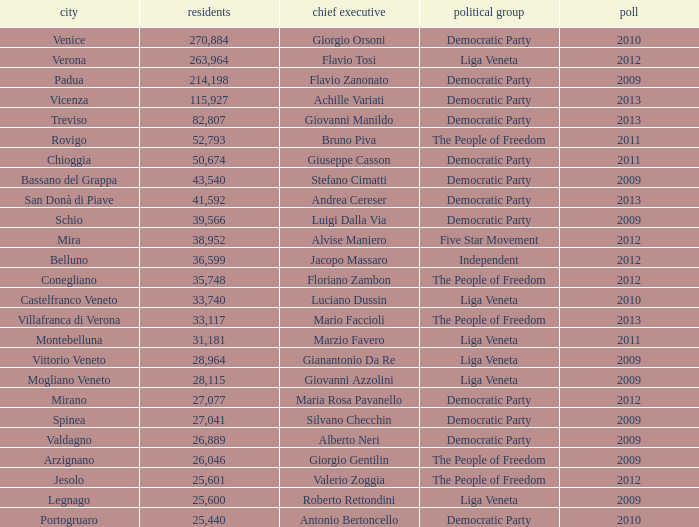In the election earlier than 2012 how many Inhabitants had a Party of five star movement? None. 